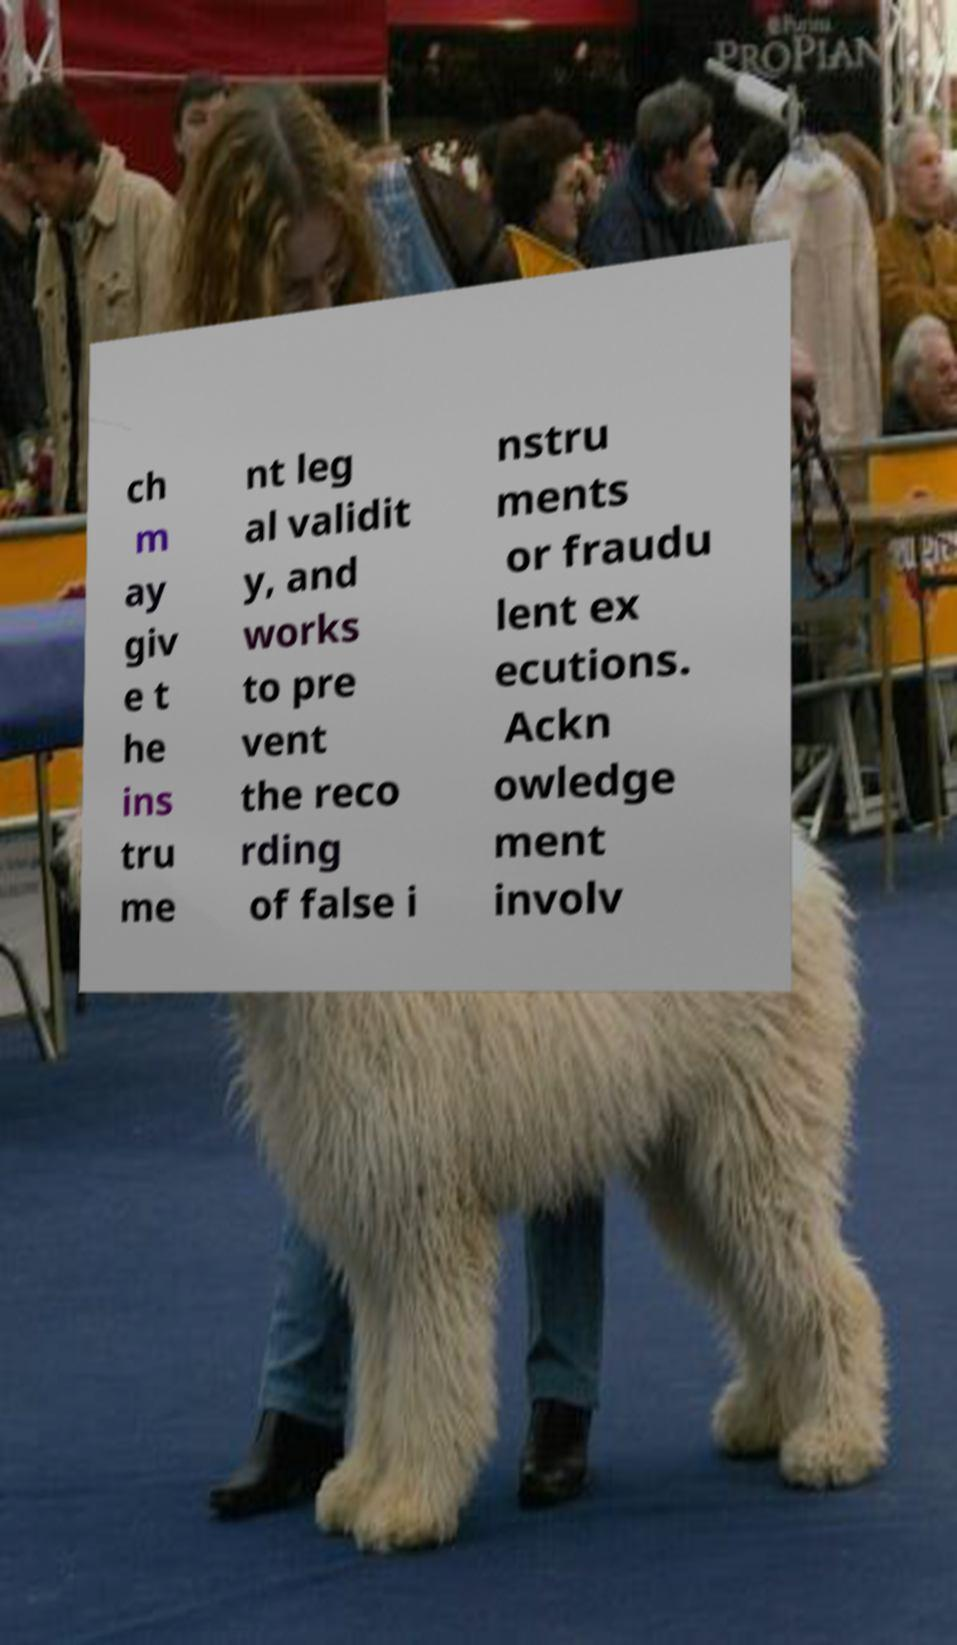Can you accurately transcribe the text from the provided image for me? ch m ay giv e t he ins tru me nt leg al validit y, and works to pre vent the reco rding of false i nstru ments or fraudu lent ex ecutions. Ackn owledge ment involv 